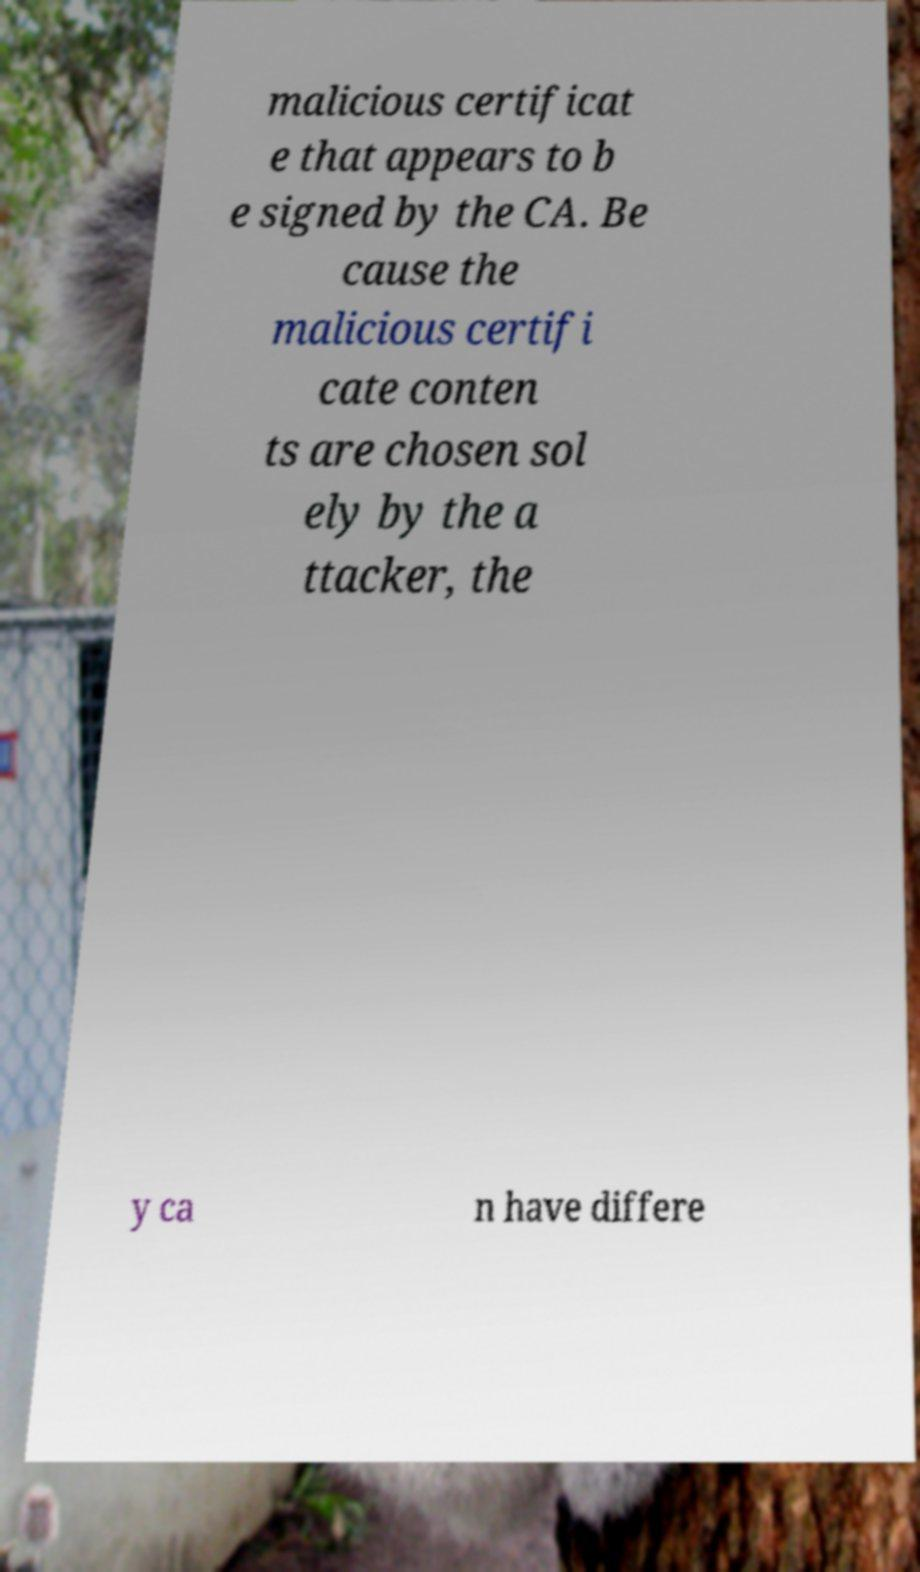There's text embedded in this image that I need extracted. Can you transcribe it verbatim? malicious certificat e that appears to b e signed by the CA. Be cause the malicious certifi cate conten ts are chosen sol ely by the a ttacker, the y ca n have differe 